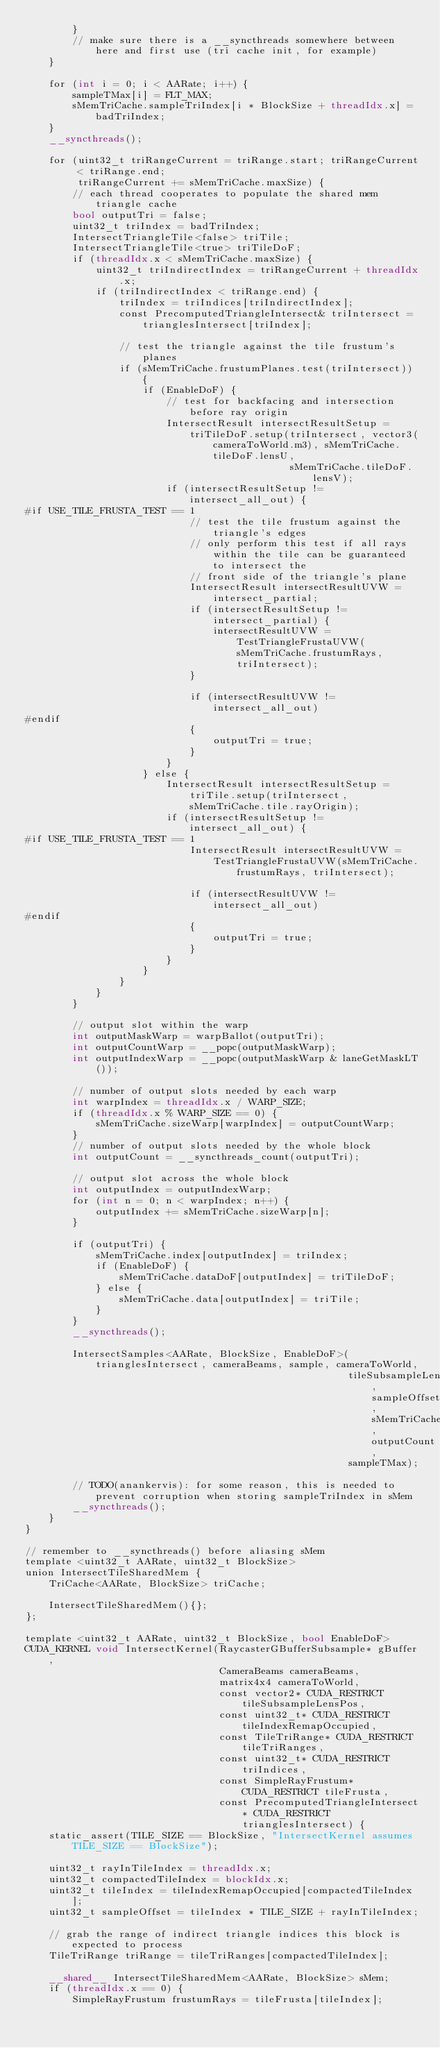Convert code to text. <code><loc_0><loc_0><loc_500><loc_500><_Cuda_>        }
        // make sure there is a __syncthreads somewhere between here and first use (tri cache init, for example)
    }

    for (int i = 0; i < AARate; i++) {
        sampleTMax[i] = FLT_MAX;
        sMemTriCache.sampleTriIndex[i * BlockSize + threadIdx.x] = badTriIndex;
    }
    __syncthreads();

    for (uint32_t triRangeCurrent = triRange.start; triRangeCurrent < triRange.end;
         triRangeCurrent += sMemTriCache.maxSize) {
        // each thread cooperates to populate the shared mem triangle cache
        bool outputTri = false;
        uint32_t triIndex = badTriIndex;
        IntersectTriangleTile<false> triTile;
        IntersectTriangleTile<true> triTileDoF;
        if (threadIdx.x < sMemTriCache.maxSize) {
            uint32_t triIndirectIndex = triRangeCurrent + threadIdx.x;
            if (triIndirectIndex < triRange.end) {
                triIndex = triIndices[triIndirectIndex];
                const PrecomputedTriangleIntersect& triIntersect = trianglesIntersect[triIndex];

                // test the triangle against the tile frustum's planes
                if (sMemTriCache.frustumPlanes.test(triIntersect)) {
                    if (EnableDoF) {
                        // test for backfacing and intersection before ray origin
                        IntersectResult intersectResultSetup =
                            triTileDoF.setup(triIntersect, vector3(cameraToWorld.m3), sMemTriCache.tileDoF.lensU,
                                             sMemTriCache.tileDoF.lensV);
                        if (intersectResultSetup != intersect_all_out) {
#if USE_TILE_FRUSTA_TEST == 1
                            // test the tile frustum against the triangle's edges
                            // only perform this test if all rays within the tile can be guaranteed to intersect the
                            // front side of the triangle's plane
                            IntersectResult intersectResultUVW = intersect_partial;
                            if (intersectResultSetup != intersect_partial) {
                                intersectResultUVW = TestTriangleFrustaUVW(sMemTriCache.frustumRays, triIntersect);
                            }

                            if (intersectResultUVW != intersect_all_out)
#endif
                            {
                                outputTri = true;
                            }
                        }
                    } else {
                        IntersectResult intersectResultSetup = triTile.setup(triIntersect, sMemTriCache.tile.rayOrigin);
                        if (intersectResultSetup != intersect_all_out) {
#if USE_TILE_FRUSTA_TEST == 1
                            IntersectResult intersectResultUVW =
                                TestTriangleFrustaUVW(sMemTriCache.frustumRays, triIntersect);

                            if (intersectResultUVW != intersect_all_out)
#endif
                            {
                                outputTri = true;
                            }
                        }
                    }
                }
            }
        }

        // output slot within the warp
        int outputMaskWarp = warpBallot(outputTri);
        int outputCountWarp = __popc(outputMaskWarp);
        int outputIndexWarp = __popc(outputMaskWarp & laneGetMaskLT());

        // number of output slots needed by each warp
        int warpIndex = threadIdx.x / WARP_SIZE;
        if (threadIdx.x % WARP_SIZE == 0) {
            sMemTriCache.sizeWarp[warpIndex] = outputCountWarp;
        }
        // number of output slots needed by the whole block
        int outputCount = __syncthreads_count(outputTri);

        // output slot across the whole block
        int outputIndex = outputIndexWarp;
        for (int n = 0; n < warpIndex; n++) {
            outputIndex += sMemTriCache.sizeWarp[n];
        }

        if (outputTri) {
            sMemTriCache.index[outputIndex] = triIndex;
            if (EnableDoF) {
                sMemTriCache.dataDoF[outputIndex] = triTileDoF;
            } else {
                sMemTriCache.data[outputIndex] = triTile;
            }
        }
        __syncthreads();

        IntersectSamples<AARate, BlockSize, EnableDoF>(trianglesIntersect, cameraBeams, sample, cameraToWorld,
                                                       tileSubsampleLensPos, sampleOffset, sMemTriCache, outputCount,
                                                       sampleTMax);

        // TODO(anankervis): for some reason, this is needed to prevent corruption when storing sampleTriIndex in sMem
        __syncthreads();
    }
}

// remember to __syncthreads() before aliasing sMem
template <uint32_t AARate, uint32_t BlockSize>
union IntersectTileSharedMem {
    TriCache<AARate, BlockSize> triCache;

    IntersectTileSharedMem(){};
};

template <uint32_t AARate, uint32_t BlockSize, bool EnableDoF>
CUDA_KERNEL void IntersectKernel(RaycasterGBufferSubsample* gBuffer,
                                 CameraBeams cameraBeams,
                                 matrix4x4 cameraToWorld,
                                 const vector2* CUDA_RESTRICT tileSubsampleLensPos,
                                 const uint32_t* CUDA_RESTRICT tileIndexRemapOccupied,
                                 const TileTriRange* CUDA_RESTRICT tileTriRanges,
                                 const uint32_t* CUDA_RESTRICT triIndices,
                                 const SimpleRayFrustum* CUDA_RESTRICT tileFrusta,
                                 const PrecomputedTriangleIntersect* CUDA_RESTRICT trianglesIntersect) {
    static_assert(TILE_SIZE == BlockSize, "IntersectKernel assumes TILE_SIZE == BlockSize");

    uint32_t rayInTileIndex = threadIdx.x;
    uint32_t compactedTileIndex = blockIdx.x;
    uint32_t tileIndex = tileIndexRemapOccupied[compactedTileIndex];
    uint32_t sampleOffset = tileIndex * TILE_SIZE + rayInTileIndex;

    // grab the range of indirect triangle indices this block is expected to process
    TileTriRange triRange = tileTriRanges[compactedTileIndex];

    __shared__ IntersectTileSharedMem<AARate, BlockSize> sMem;
    if (threadIdx.x == 0) {
        SimpleRayFrustum frustumRays = tileFrusta[tileIndex];</code> 